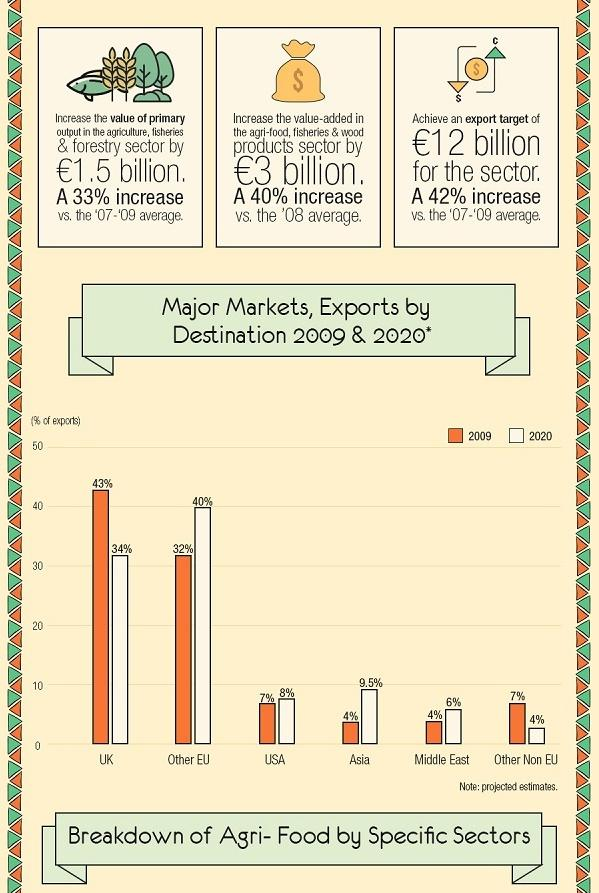Highlight a few significant elements in this photo. The export of goods to destinations outside the European Union increased by 8% in the time period 2009-2020, with the largest increase being to "Other EU" countries. In 2009, exports to the USA accounted for 7% of total exports. The export of goods to a particular destination decreased by 9% in the time period 2009-2020, which was primarily to the United Kingdom. In 2020, 4% of the country's exports were directed to "Other Non EU" destinations. The primary output value in the agriculture, fisheries, and forestry sector increased by 33% in the given year. 